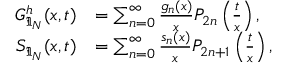<formula> <loc_0><loc_0><loc_500><loc_500>\begin{array} { r l } { G _ { \mathfrak { I } _ { N } } ^ { h } ( x , t ) } & { = \sum _ { n = 0 } ^ { \infty } \frac { g _ { n } ( x ) } { x } P _ { 2 n } \left ( \frac { t } { x } \right ) , } \\ { S _ { \mathfrak { I } _ { N } } ( x , t ) } & { = \sum _ { n = 0 } ^ { \infty } \frac { s _ { n } ( x ) } { x } P _ { 2 n + 1 } \left ( \frac { t } { x } \right ) , } \end{array}</formula> 